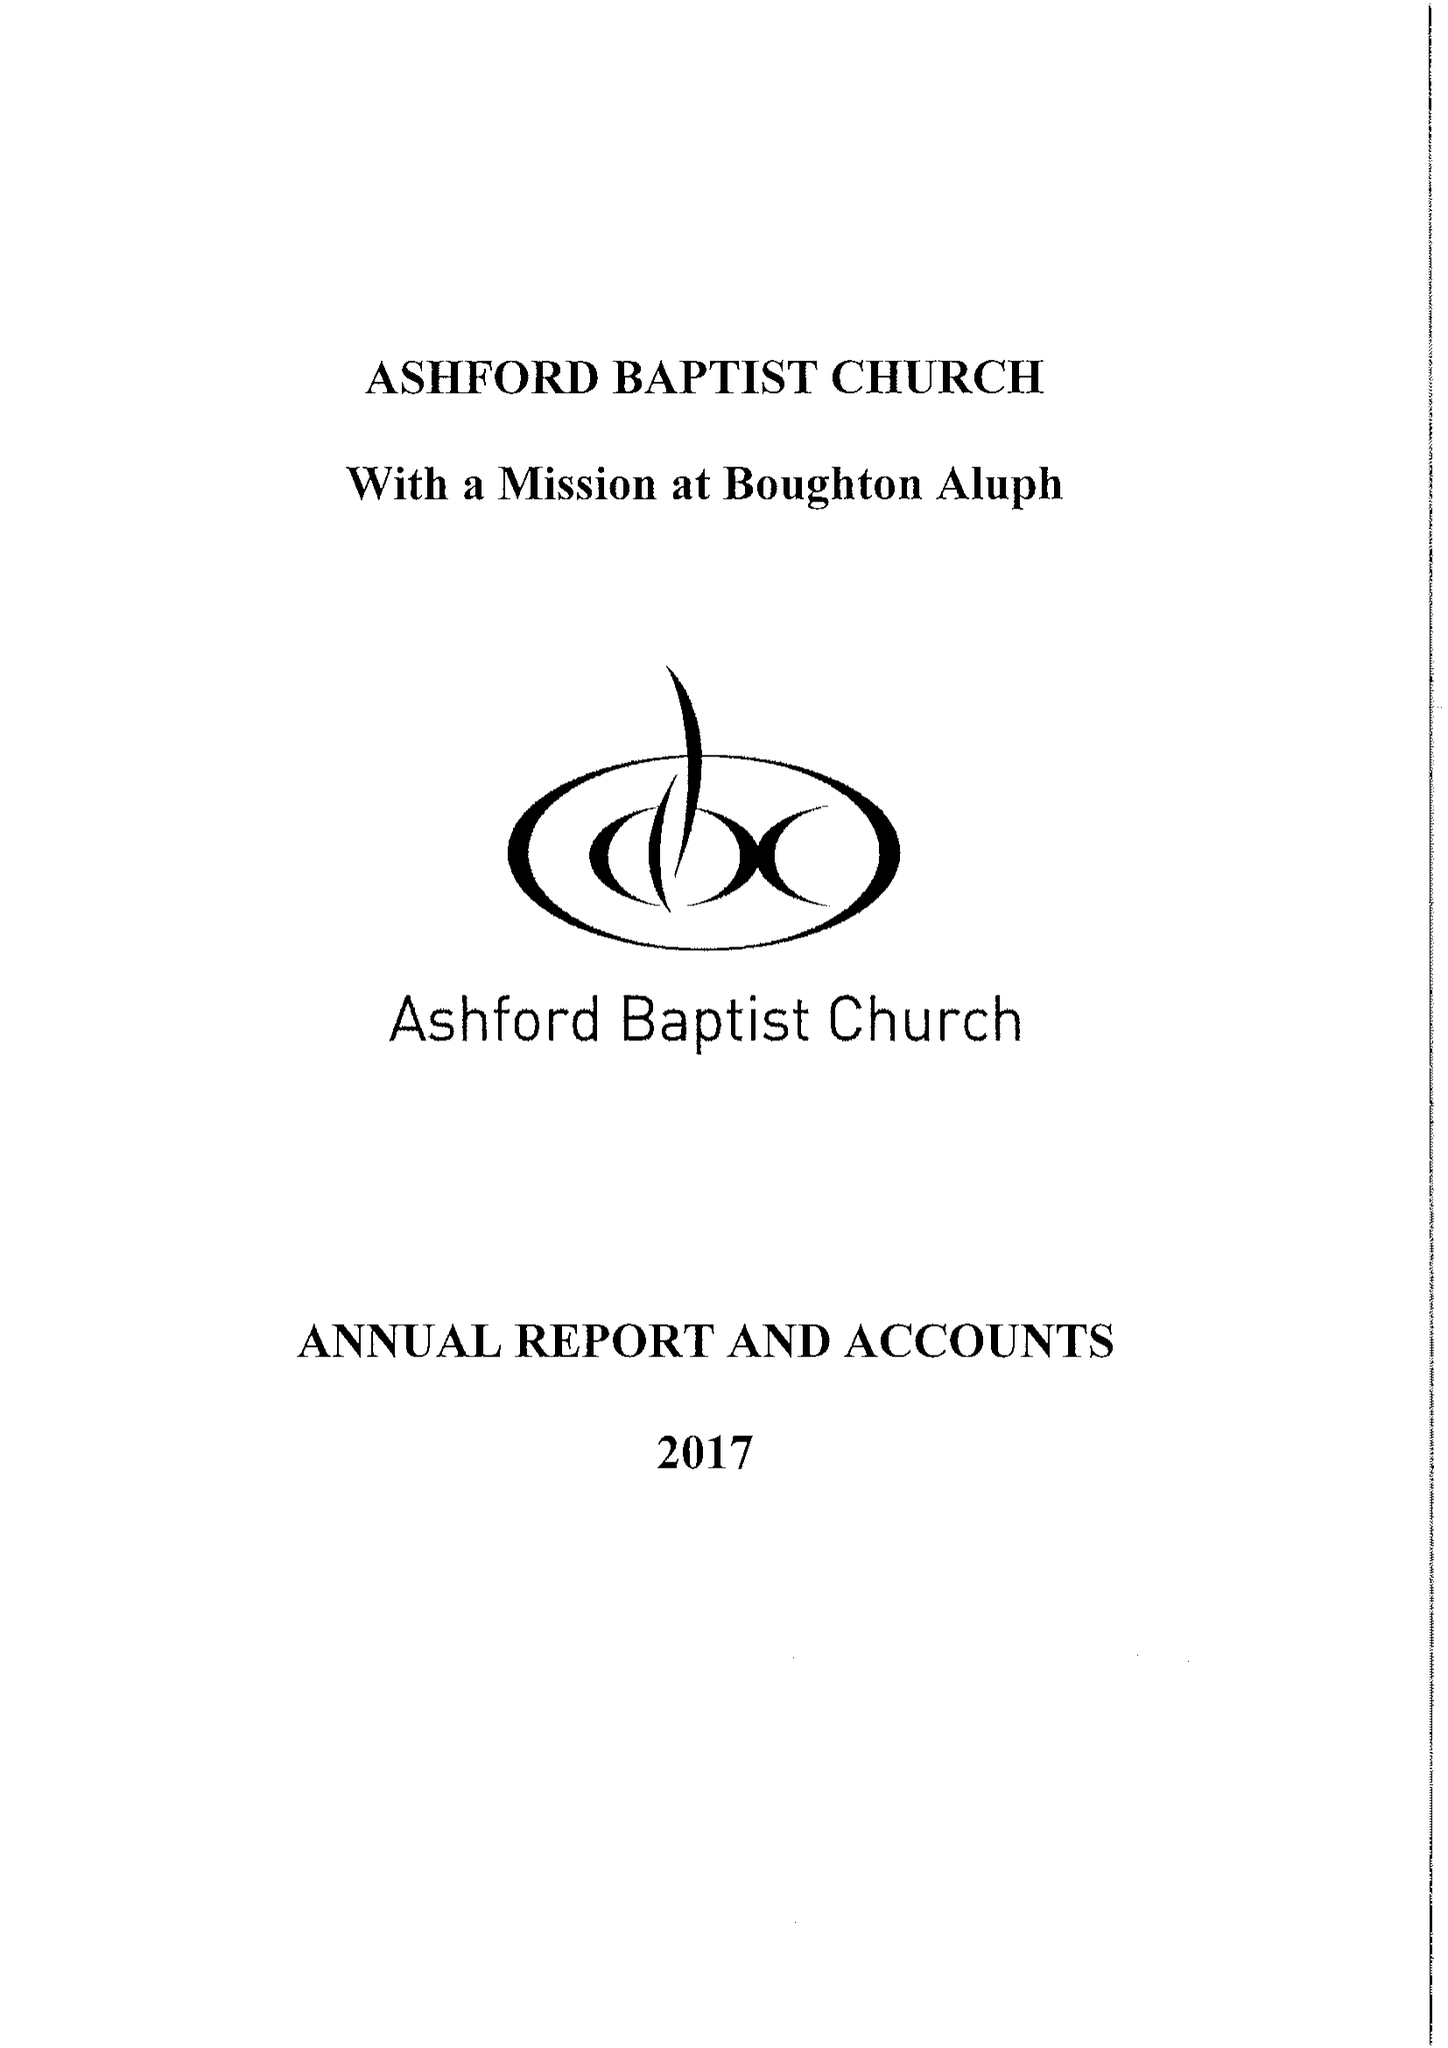What is the value for the report_date?
Answer the question using a single word or phrase. 2017-12-31 